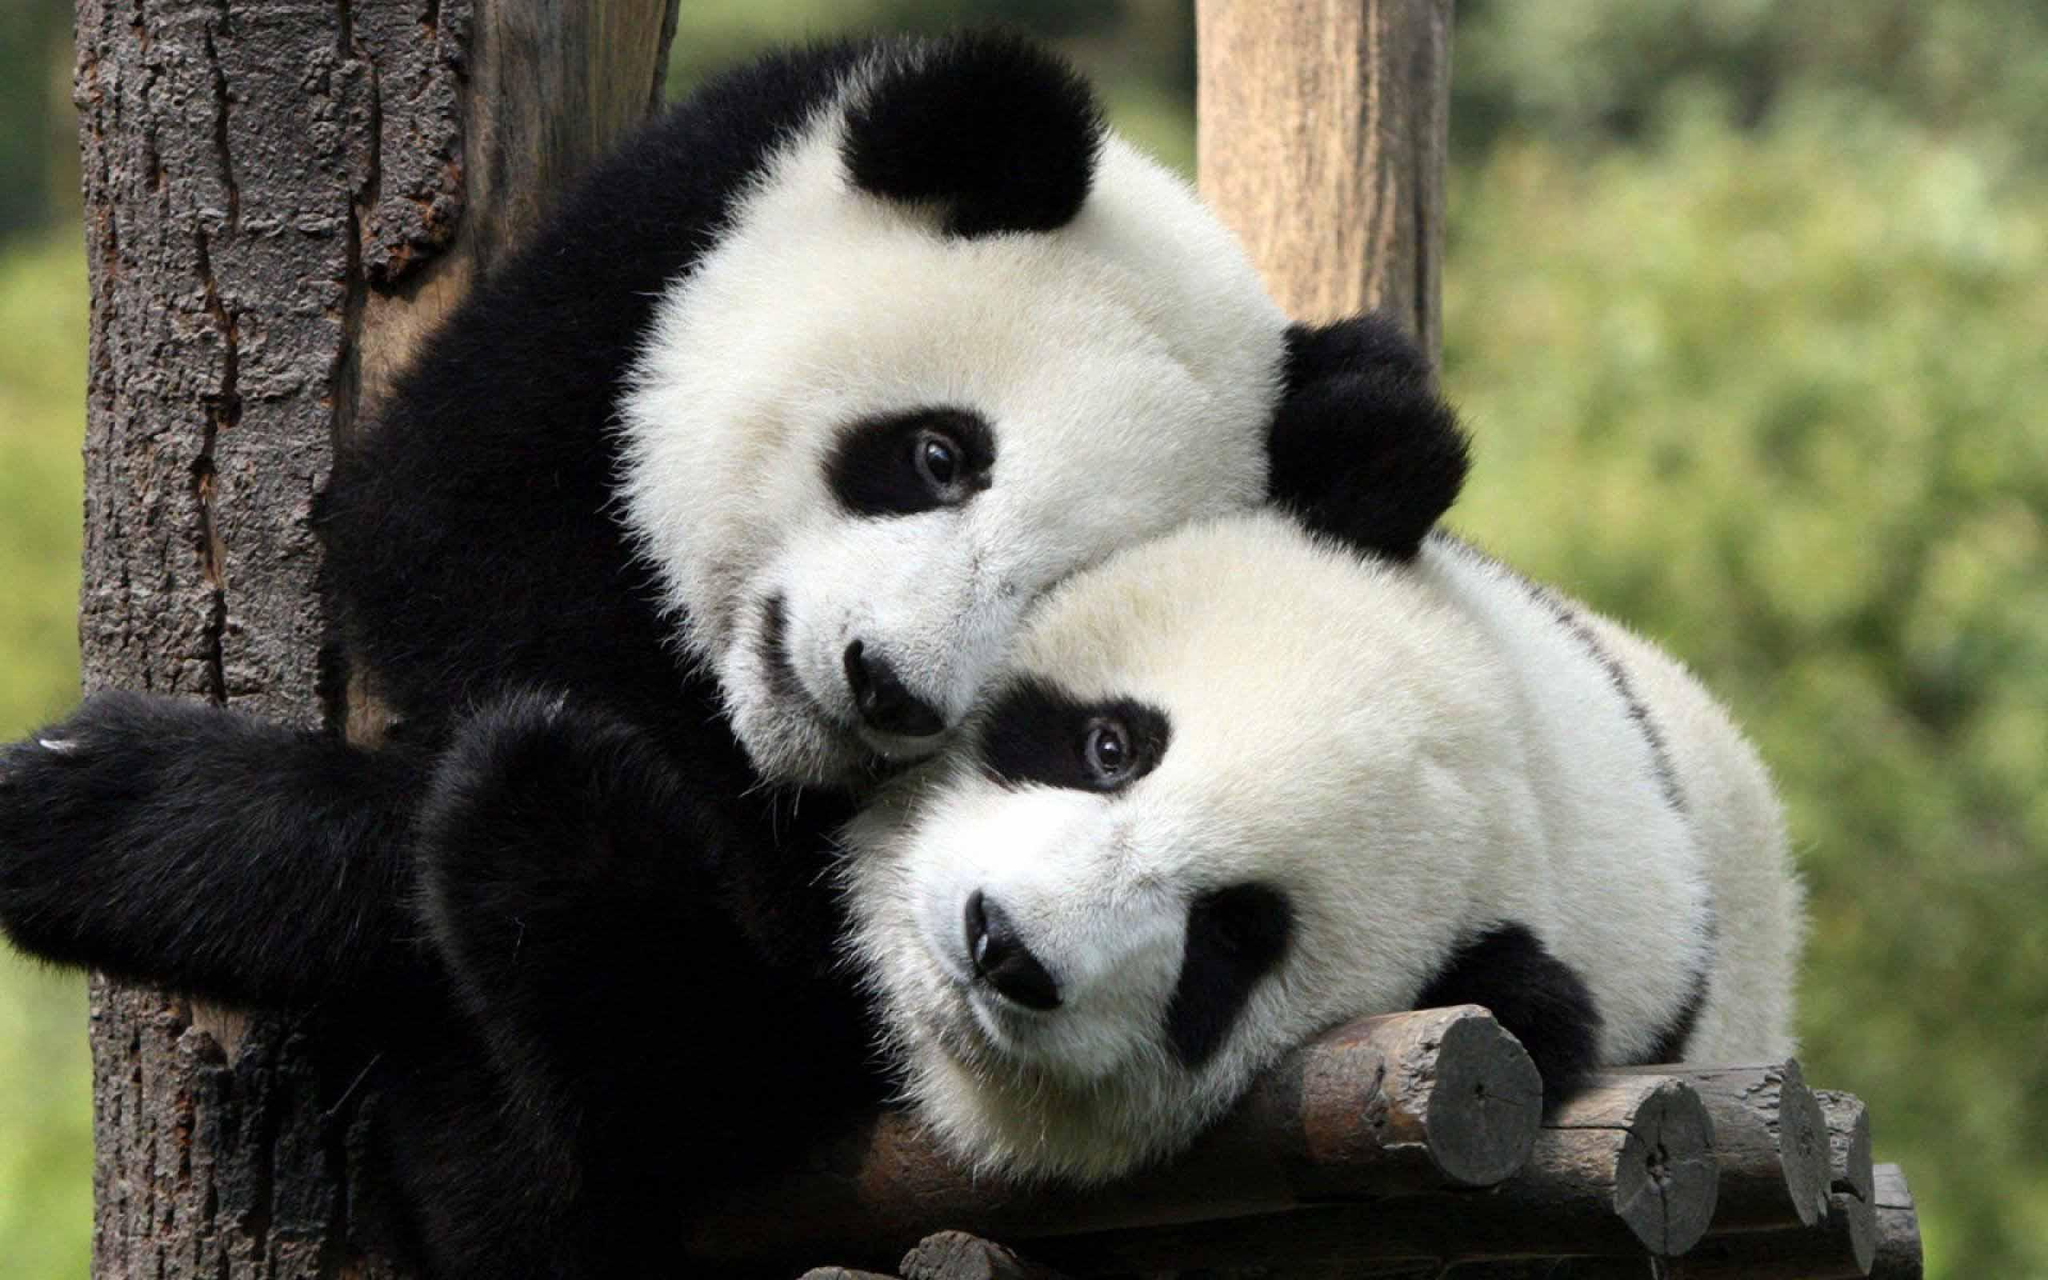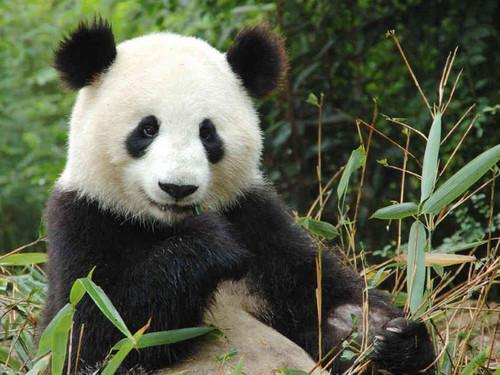The first image is the image on the left, the second image is the image on the right. Considering the images on both sides, is "Two pandas are embracing each other." valid? Answer yes or no. Yes. 